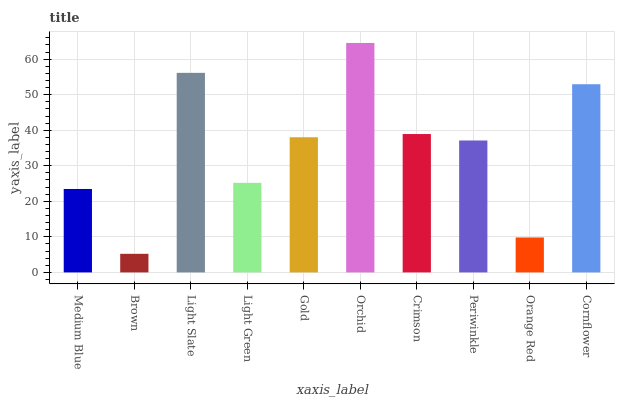Is Brown the minimum?
Answer yes or no. Yes. Is Orchid the maximum?
Answer yes or no. Yes. Is Light Slate the minimum?
Answer yes or no. No. Is Light Slate the maximum?
Answer yes or no. No. Is Light Slate greater than Brown?
Answer yes or no. Yes. Is Brown less than Light Slate?
Answer yes or no. Yes. Is Brown greater than Light Slate?
Answer yes or no. No. Is Light Slate less than Brown?
Answer yes or no. No. Is Gold the high median?
Answer yes or no. Yes. Is Periwinkle the low median?
Answer yes or no. Yes. Is Cornflower the high median?
Answer yes or no. No. Is Cornflower the low median?
Answer yes or no. No. 